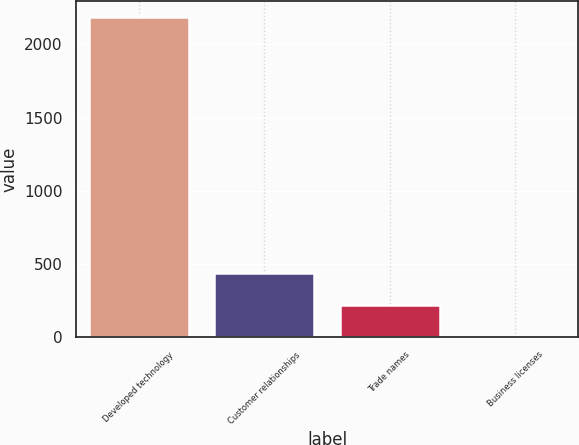Convert chart. <chart><loc_0><loc_0><loc_500><loc_500><bar_chart><fcel>Developed technology<fcel>Customer relationships<fcel>Trade names<fcel>Business licenses<nl><fcel>2186.8<fcel>439.12<fcel>220.66<fcel>2.2<nl></chart> 